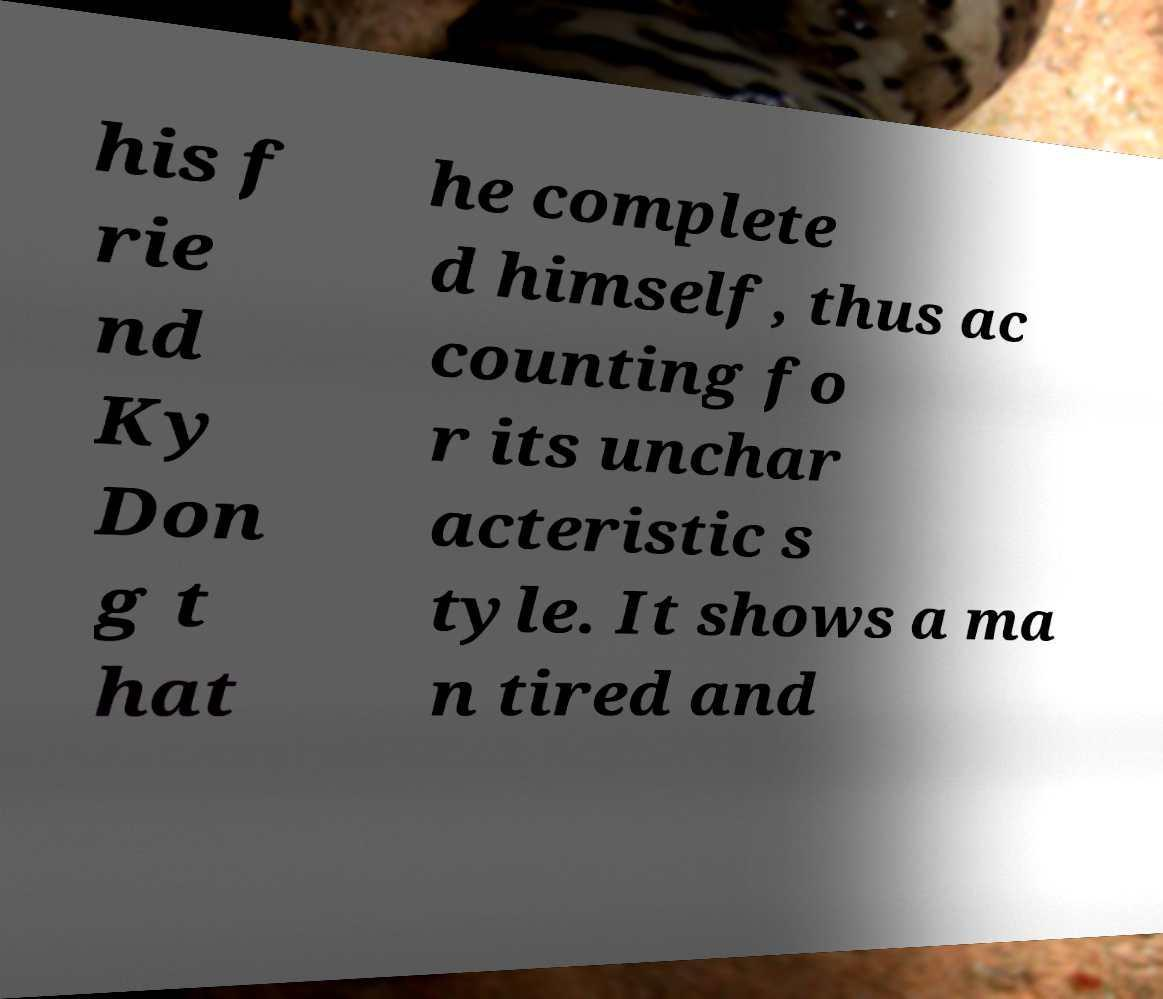There's text embedded in this image that I need extracted. Can you transcribe it verbatim? his f rie nd Ky Don g t hat he complete d himself, thus ac counting fo r its unchar acteristic s tyle. It shows a ma n tired and 